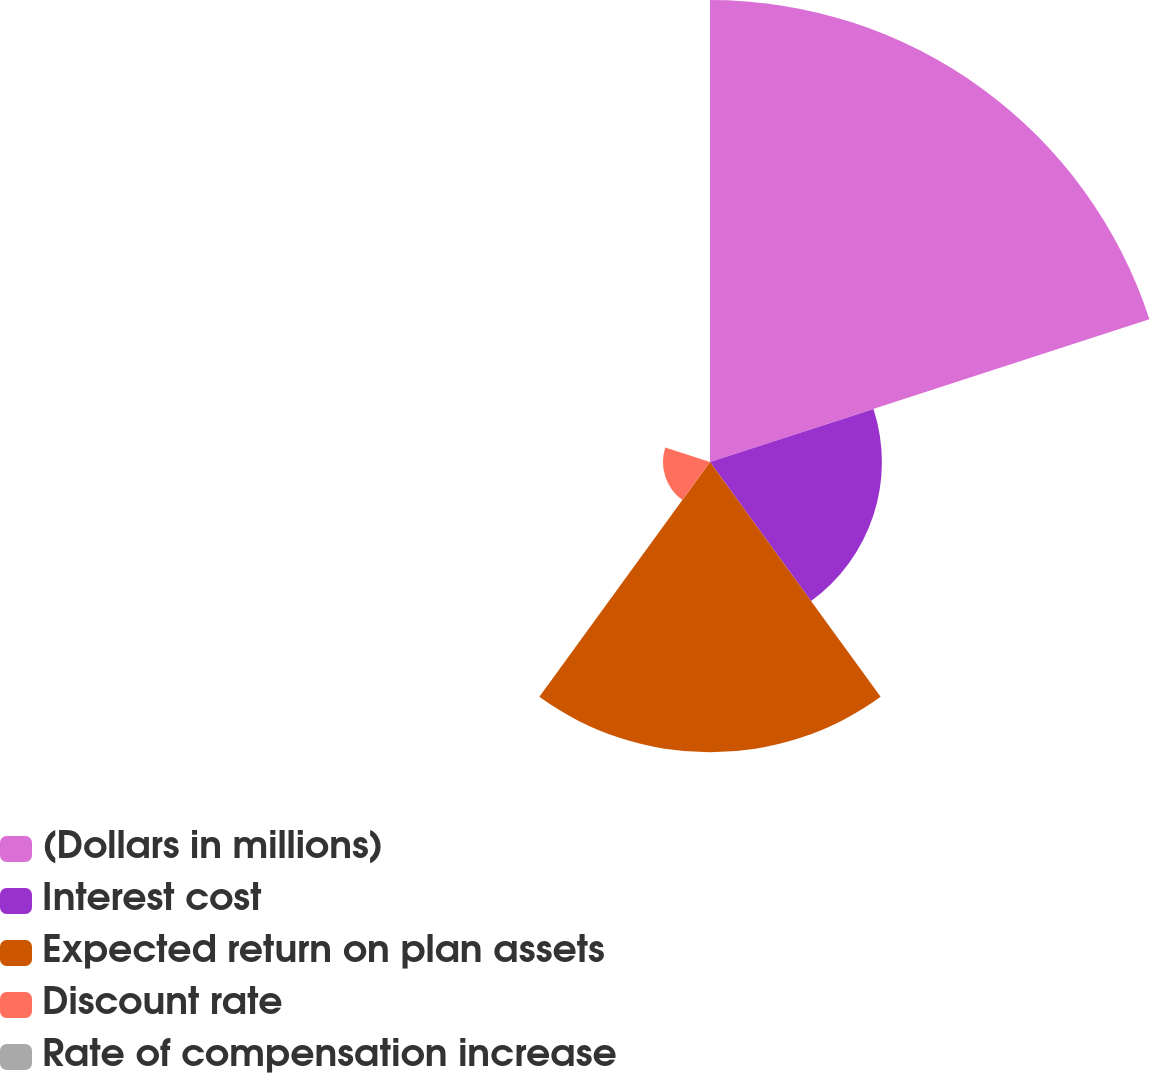Convert chart to OTSL. <chart><loc_0><loc_0><loc_500><loc_500><pie_chart><fcel>(Dollars in millions)<fcel>Interest cost<fcel>Expected return on plan assets<fcel>Discount rate<fcel>Rate of compensation increase<nl><fcel>47.52%<fcel>17.68%<fcel>29.86%<fcel>4.84%<fcel>0.09%<nl></chart> 